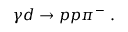Convert formula to latex. <formula><loc_0><loc_0><loc_500><loc_500>\gamma d \rightarrow p p \pi ^ { - } \ .</formula> 